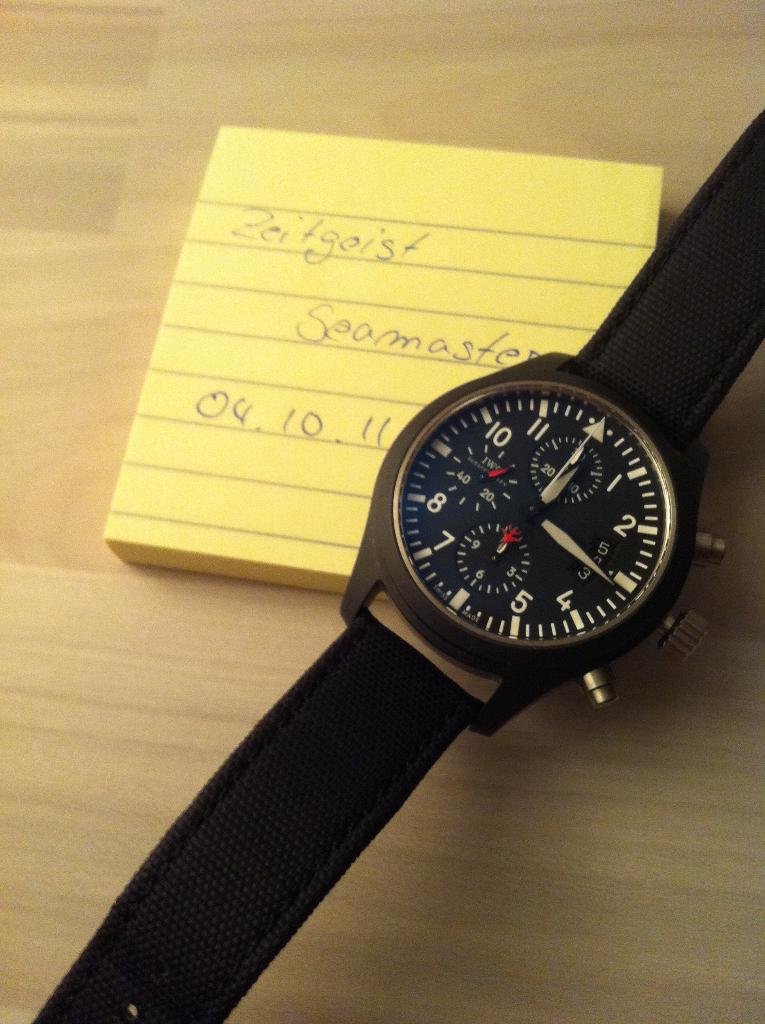What time is the watch showing?
Your response must be concise. 12:15. What date is written on the yellow tablet?
Make the answer very short. 04.10.11. 